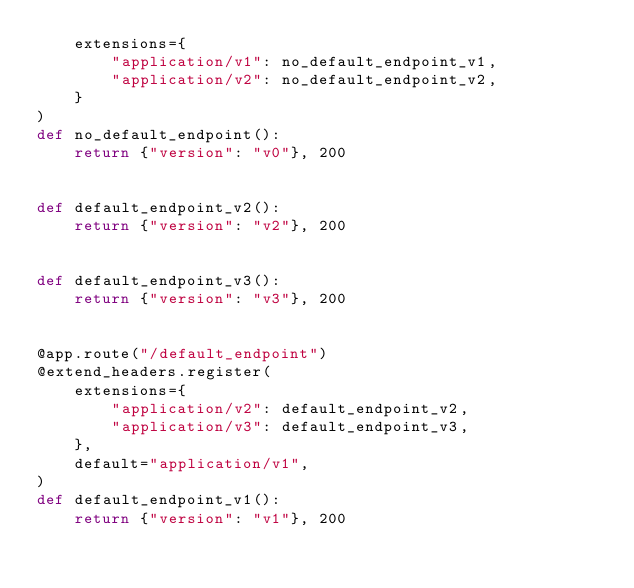Convert code to text. <code><loc_0><loc_0><loc_500><loc_500><_Python_>    extensions={
        "application/v1": no_default_endpoint_v1,
        "application/v2": no_default_endpoint_v2,
    }
)
def no_default_endpoint():
    return {"version": "v0"}, 200


def default_endpoint_v2():
    return {"version": "v2"}, 200


def default_endpoint_v3():
    return {"version": "v3"}, 200


@app.route("/default_endpoint")
@extend_headers.register(
    extensions={
        "application/v2": default_endpoint_v2,
        "application/v3": default_endpoint_v3,
    },
    default="application/v1",
)
def default_endpoint_v1():
    return {"version": "v1"}, 200
</code> 